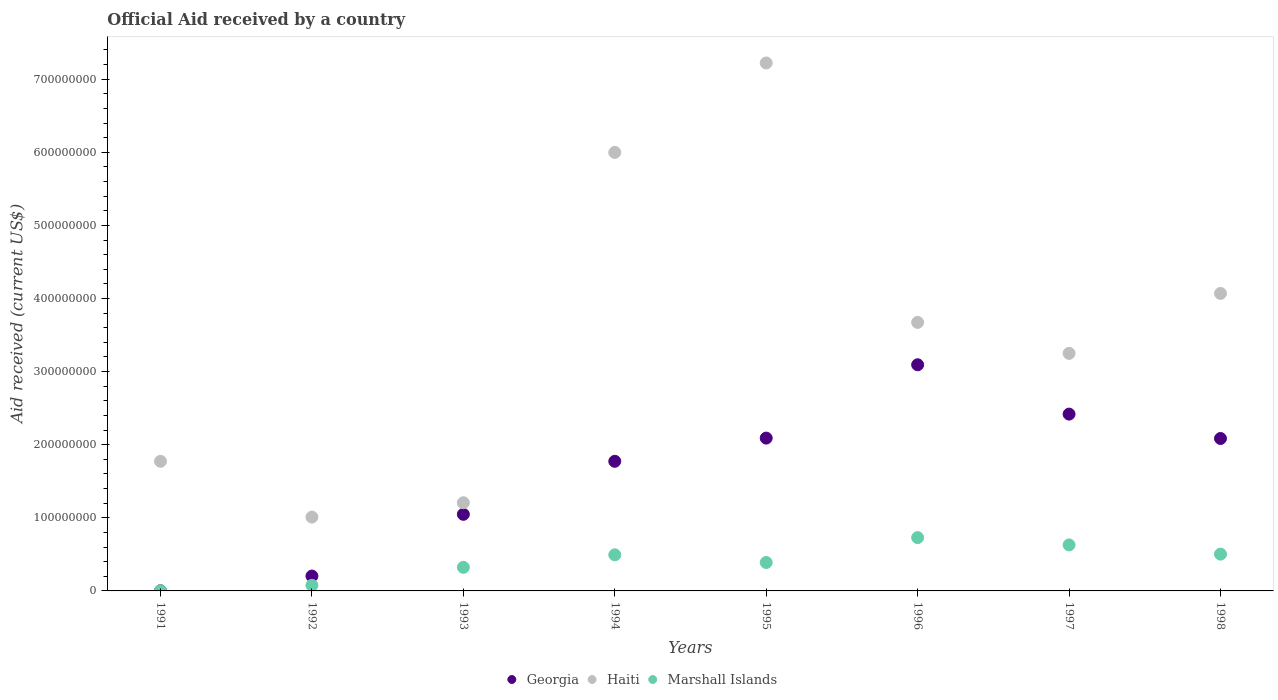How many different coloured dotlines are there?
Provide a short and direct response. 3. Is the number of dotlines equal to the number of legend labels?
Make the answer very short. Yes. What is the net official aid received in Haiti in 1991?
Your answer should be compact. 1.77e+08. Across all years, what is the maximum net official aid received in Haiti?
Offer a very short reply. 7.22e+08. Across all years, what is the minimum net official aid received in Marshall Islands?
Provide a short and direct response. 2.80e+05. In which year was the net official aid received in Haiti minimum?
Provide a succinct answer. 1992. What is the total net official aid received in Haiti in the graph?
Offer a terse response. 2.82e+09. What is the difference between the net official aid received in Georgia in 1991 and that in 1994?
Provide a succinct answer. -1.77e+08. What is the difference between the net official aid received in Georgia in 1992 and the net official aid received in Marshall Islands in 1996?
Make the answer very short. -5.26e+07. What is the average net official aid received in Haiti per year?
Ensure brevity in your answer.  3.53e+08. In the year 1996, what is the difference between the net official aid received in Georgia and net official aid received in Marshall Islands?
Give a very brief answer. 2.36e+08. In how many years, is the net official aid received in Haiti greater than 520000000 US$?
Provide a succinct answer. 2. What is the ratio of the net official aid received in Marshall Islands in 1994 to that in 1998?
Keep it short and to the point. 0.98. Is the net official aid received in Haiti in 1994 less than that in 1995?
Ensure brevity in your answer.  Yes. Is the difference between the net official aid received in Georgia in 1993 and 1997 greater than the difference between the net official aid received in Marshall Islands in 1993 and 1997?
Ensure brevity in your answer.  No. What is the difference between the highest and the second highest net official aid received in Haiti?
Offer a very short reply. 1.22e+08. What is the difference between the highest and the lowest net official aid received in Haiti?
Ensure brevity in your answer.  6.21e+08. In how many years, is the net official aid received in Haiti greater than the average net official aid received in Haiti taken over all years?
Offer a very short reply. 4. Is the sum of the net official aid received in Haiti in 1993 and 1997 greater than the maximum net official aid received in Georgia across all years?
Your answer should be compact. Yes. Is it the case that in every year, the sum of the net official aid received in Marshall Islands and net official aid received in Haiti  is greater than the net official aid received in Georgia?
Make the answer very short. Yes. Does the net official aid received in Haiti monotonically increase over the years?
Give a very brief answer. No. Is the net official aid received in Haiti strictly less than the net official aid received in Georgia over the years?
Your answer should be compact. No. How many dotlines are there?
Give a very brief answer. 3. How many years are there in the graph?
Your answer should be compact. 8. What is the difference between two consecutive major ticks on the Y-axis?
Keep it short and to the point. 1.00e+08. Are the values on the major ticks of Y-axis written in scientific E-notation?
Offer a very short reply. No. Does the graph contain any zero values?
Your answer should be very brief. No. Where does the legend appear in the graph?
Make the answer very short. Bottom center. How many legend labels are there?
Give a very brief answer. 3. What is the title of the graph?
Keep it short and to the point. Official Aid received by a country. What is the label or title of the Y-axis?
Provide a short and direct response. Aid received (current US$). What is the Aid received (current US$) of Haiti in 1991?
Offer a very short reply. 1.77e+08. What is the Aid received (current US$) in Georgia in 1992?
Your response must be concise. 2.04e+07. What is the Aid received (current US$) of Haiti in 1992?
Provide a succinct answer. 1.01e+08. What is the Aid received (current US$) in Marshall Islands in 1992?
Give a very brief answer. 7.68e+06. What is the Aid received (current US$) in Georgia in 1993?
Your answer should be very brief. 1.05e+08. What is the Aid received (current US$) in Haiti in 1993?
Make the answer very short. 1.21e+08. What is the Aid received (current US$) of Marshall Islands in 1993?
Offer a very short reply. 3.22e+07. What is the Aid received (current US$) in Georgia in 1994?
Provide a succinct answer. 1.77e+08. What is the Aid received (current US$) in Haiti in 1994?
Provide a short and direct response. 6.00e+08. What is the Aid received (current US$) in Marshall Islands in 1994?
Offer a terse response. 4.94e+07. What is the Aid received (current US$) in Georgia in 1995?
Your response must be concise. 2.09e+08. What is the Aid received (current US$) in Haiti in 1995?
Provide a succinct answer. 7.22e+08. What is the Aid received (current US$) of Marshall Islands in 1995?
Your answer should be very brief. 3.89e+07. What is the Aid received (current US$) of Georgia in 1996?
Provide a short and direct response. 3.09e+08. What is the Aid received (current US$) in Haiti in 1996?
Give a very brief answer. 3.67e+08. What is the Aid received (current US$) of Marshall Islands in 1996?
Provide a short and direct response. 7.29e+07. What is the Aid received (current US$) of Georgia in 1997?
Make the answer very short. 2.42e+08. What is the Aid received (current US$) in Haiti in 1997?
Give a very brief answer. 3.25e+08. What is the Aid received (current US$) in Marshall Islands in 1997?
Provide a succinct answer. 6.29e+07. What is the Aid received (current US$) in Georgia in 1998?
Provide a succinct answer. 2.09e+08. What is the Aid received (current US$) of Haiti in 1998?
Give a very brief answer. 4.07e+08. What is the Aid received (current US$) of Marshall Islands in 1998?
Your response must be concise. 5.03e+07. Across all years, what is the maximum Aid received (current US$) of Georgia?
Make the answer very short. 3.09e+08. Across all years, what is the maximum Aid received (current US$) in Haiti?
Make the answer very short. 7.22e+08. Across all years, what is the maximum Aid received (current US$) of Marshall Islands?
Offer a terse response. 7.29e+07. Across all years, what is the minimum Aid received (current US$) in Haiti?
Keep it short and to the point. 1.01e+08. What is the total Aid received (current US$) of Georgia in the graph?
Offer a very short reply. 1.27e+09. What is the total Aid received (current US$) of Haiti in the graph?
Ensure brevity in your answer.  2.82e+09. What is the total Aid received (current US$) in Marshall Islands in the graph?
Ensure brevity in your answer.  3.15e+08. What is the difference between the Aid received (current US$) of Georgia in 1991 and that in 1992?
Your response must be concise. -2.01e+07. What is the difference between the Aid received (current US$) in Haiti in 1991 and that in 1992?
Offer a very short reply. 7.63e+07. What is the difference between the Aid received (current US$) of Marshall Islands in 1991 and that in 1992?
Ensure brevity in your answer.  -7.40e+06. What is the difference between the Aid received (current US$) of Georgia in 1991 and that in 1993?
Make the answer very short. -1.05e+08. What is the difference between the Aid received (current US$) in Haiti in 1991 and that in 1993?
Keep it short and to the point. 5.66e+07. What is the difference between the Aid received (current US$) of Marshall Islands in 1991 and that in 1993?
Offer a very short reply. -3.20e+07. What is the difference between the Aid received (current US$) in Georgia in 1991 and that in 1994?
Provide a short and direct response. -1.77e+08. What is the difference between the Aid received (current US$) in Haiti in 1991 and that in 1994?
Your answer should be very brief. -4.23e+08. What is the difference between the Aid received (current US$) of Marshall Islands in 1991 and that in 1994?
Your answer should be very brief. -4.91e+07. What is the difference between the Aid received (current US$) in Georgia in 1991 and that in 1995?
Ensure brevity in your answer.  -2.09e+08. What is the difference between the Aid received (current US$) in Haiti in 1991 and that in 1995?
Give a very brief answer. -5.45e+08. What is the difference between the Aid received (current US$) of Marshall Islands in 1991 and that in 1995?
Offer a very short reply. -3.86e+07. What is the difference between the Aid received (current US$) of Georgia in 1991 and that in 1996?
Ensure brevity in your answer.  -3.09e+08. What is the difference between the Aid received (current US$) of Haiti in 1991 and that in 1996?
Make the answer very short. -1.90e+08. What is the difference between the Aid received (current US$) in Marshall Islands in 1991 and that in 1996?
Make the answer very short. -7.27e+07. What is the difference between the Aid received (current US$) in Georgia in 1991 and that in 1997?
Give a very brief answer. -2.42e+08. What is the difference between the Aid received (current US$) of Haiti in 1991 and that in 1997?
Your response must be concise. -1.48e+08. What is the difference between the Aid received (current US$) of Marshall Islands in 1991 and that in 1997?
Offer a very short reply. -6.26e+07. What is the difference between the Aid received (current US$) of Georgia in 1991 and that in 1998?
Your response must be concise. -2.08e+08. What is the difference between the Aid received (current US$) of Haiti in 1991 and that in 1998?
Provide a short and direct response. -2.30e+08. What is the difference between the Aid received (current US$) in Marshall Islands in 1991 and that in 1998?
Your answer should be compact. -5.00e+07. What is the difference between the Aid received (current US$) of Georgia in 1992 and that in 1993?
Ensure brevity in your answer.  -8.44e+07. What is the difference between the Aid received (current US$) in Haiti in 1992 and that in 1993?
Your answer should be compact. -1.97e+07. What is the difference between the Aid received (current US$) in Marshall Islands in 1992 and that in 1993?
Provide a short and direct response. -2.46e+07. What is the difference between the Aid received (current US$) in Georgia in 1992 and that in 1994?
Your answer should be compact. -1.57e+08. What is the difference between the Aid received (current US$) in Haiti in 1992 and that in 1994?
Give a very brief answer. -4.99e+08. What is the difference between the Aid received (current US$) in Marshall Islands in 1992 and that in 1994?
Your response must be concise. -4.17e+07. What is the difference between the Aid received (current US$) of Georgia in 1992 and that in 1995?
Offer a very short reply. -1.89e+08. What is the difference between the Aid received (current US$) of Haiti in 1992 and that in 1995?
Your answer should be compact. -6.21e+08. What is the difference between the Aid received (current US$) of Marshall Islands in 1992 and that in 1995?
Provide a short and direct response. -3.12e+07. What is the difference between the Aid received (current US$) of Georgia in 1992 and that in 1996?
Your answer should be compact. -2.89e+08. What is the difference between the Aid received (current US$) in Haiti in 1992 and that in 1996?
Ensure brevity in your answer.  -2.66e+08. What is the difference between the Aid received (current US$) in Marshall Islands in 1992 and that in 1996?
Your answer should be very brief. -6.53e+07. What is the difference between the Aid received (current US$) in Georgia in 1992 and that in 1997?
Give a very brief answer. -2.22e+08. What is the difference between the Aid received (current US$) in Haiti in 1992 and that in 1997?
Provide a short and direct response. -2.24e+08. What is the difference between the Aid received (current US$) of Marshall Islands in 1992 and that in 1997?
Your answer should be compact. -5.52e+07. What is the difference between the Aid received (current US$) of Georgia in 1992 and that in 1998?
Keep it short and to the point. -1.88e+08. What is the difference between the Aid received (current US$) of Haiti in 1992 and that in 1998?
Provide a short and direct response. -3.06e+08. What is the difference between the Aid received (current US$) in Marshall Islands in 1992 and that in 1998?
Your answer should be very brief. -4.26e+07. What is the difference between the Aid received (current US$) in Georgia in 1993 and that in 1994?
Your answer should be compact. -7.25e+07. What is the difference between the Aid received (current US$) in Haiti in 1993 and that in 1994?
Offer a very short reply. -4.79e+08. What is the difference between the Aid received (current US$) of Marshall Islands in 1993 and that in 1994?
Make the answer very short. -1.71e+07. What is the difference between the Aid received (current US$) of Georgia in 1993 and that in 1995?
Your response must be concise. -1.04e+08. What is the difference between the Aid received (current US$) in Haiti in 1993 and that in 1995?
Ensure brevity in your answer.  -6.02e+08. What is the difference between the Aid received (current US$) in Marshall Islands in 1993 and that in 1995?
Offer a terse response. -6.63e+06. What is the difference between the Aid received (current US$) in Georgia in 1993 and that in 1996?
Your answer should be very brief. -2.05e+08. What is the difference between the Aid received (current US$) of Haiti in 1993 and that in 1996?
Your answer should be compact. -2.47e+08. What is the difference between the Aid received (current US$) in Marshall Islands in 1993 and that in 1996?
Give a very brief answer. -4.07e+07. What is the difference between the Aid received (current US$) of Georgia in 1993 and that in 1997?
Your answer should be very brief. -1.37e+08. What is the difference between the Aid received (current US$) in Haiti in 1993 and that in 1997?
Make the answer very short. -2.04e+08. What is the difference between the Aid received (current US$) in Marshall Islands in 1993 and that in 1997?
Make the answer very short. -3.07e+07. What is the difference between the Aid received (current US$) in Georgia in 1993 and that in 1998?
Provide a short and direct response. -1.04e+08. What is the difference between the Aid received (current US$) of Haiti in 1993 and that in 1998?
Make the answer very short. -2.86e+08. What is the difference between the Aid received (current US$) of Marshall Islands in 1993 and that in 1998?
Your answer should be very brief. -1.81e+07. What is the difference between the Aid received (current US$) in Georgia in 1994 and that in 1995?
Give a very brief answer. -3.17e+07. What is the difference between the Aid received (current US$) in Haiti in 1994 and that in 1995?
Provide a short and direct response. -1.22e+08. What is the difference between the Aid received (current US$) in Marshall Islands in 1994 and that in 1995?
Ensure brevity in your answer.  1.05e+07. What is the difference between the Aid received (current US$) in Georgia in 1994 and that in 1996?
Your answer should be very brief. -1.32e+08. What is the difference between the Aid received (current US$) in Haiti in 1994 and that in 1996?
Your response must be concise. 2.33e+08. What is the difference between the Aid received (current US$) of Marshall Islands in 1994 and that in 1996?
Offer a terse response. -2.36e+07. What is the difference between the Aid received (current US$) in Georgia in 1994 and that in 1997?
Make the answer very short. -6.46e+07. What is the difference between the Aid received (current US$) of Haiti in 1994 and that in 1997?
Offer a terse response. 2.75e+08. What is the difference between the Aid received (current US$) of Marshall Islands in 1994 and that in 1997?
Your answer should be compact. -1.36e+07. What is the difference between the Aid received (current US$) of Georgia in 1994 and that in 1998?
Provide a short and direct response. -3.12e+07. What is the difference between the Aid received (current US$) in Haiti in 1994 and that in 1998?
Provide a short and direct response. 1.93e+08. What is the difference between the Aid received (current US$) in Marshall Islands in 1994 and that in 1998?
Your answer should be compact. -9.70e+05. What is the difference between the Aid received (current US$) of Georgia in 1995 and that in 1996?
Provide a succinct answer. -1.00e+08. What is the difference between the Aid received (current US$) of Haiti in 1995 and that in 1996?
Your answer should be compact. 3.55e+08. What is the difference between the Aid received (current US$) in Marshall Islands in 1995 and that in 1996?
Your answer should be very brief. -3.41e+07. What is the difference between the Aid received (current US$) in Georgia in 1995 and that in 1997?
Offer a terse response. -3.28e+07. What is the difference between the Aid received (current US$) in Haiti in 1995 and that in 1997?
Ensure brevity in your answer.  3.97e+08. What is the difference between the Aid received (current US$) in Marshall Islands in 1995 and that in 1997?
Your answer should be very brief. -2.40e+07. What is the difference between the Aid received (current US$) in Georgia in 1995 and that in 1998?
Your answer should be very brief. 5.40e+05. What is the difference between the Aid received (current US$) in Haiti in 1995 and that in 1998?
Offer a very short reply. 3.15e+08. What is the difference between the Aid received (current US$) of Marshall Islands in 1995 and that in 1998?
Your response must be concise. -1.14e+07. What is the difference between the Aid received (current US$) in Georgia in 1996 and that in 1997?
Your response must be concise. 6.75e+07. What is the difference between the Aid received (current US$) of Haiti in 1996 and that in 1997?
Make the answer very short. 4.23e+07. What is the difference between the Aid received (current US$) in Marshall Islands in 1996 and that in 1997?
Offer a terse response. 1.00e+07. What is the difference between the Aid received (current US$) in Georgia in 1996 and that in 1998?
Provide a succinct answer. 1.01e+08. What is the difference between the Aid received (current US$) in Haiti in 1996 and that in 1998?
Offer a very short reply. -3.97e+07. What is the difference between the Aid received (current US$) in Marshall Islands in 1996 and that in 1998?
Offer a terse response. 2.26e+07. What is the difference between the Aid received (current US$) of Georgia in 1997 and that in 1998?
Offer a terse response. 3.34e+07. What is the difference between the Aid received (current US$) in Haiti in 1997 and that in 1998?
Offer a very short reply. -8.20e+07. What is the difference between the Aid received (current US$) in Marshall Islands in 1997 and that in 1998?
Ensure brevity in your answer.  1.26e+07. What is the difference between the Aid received (current US$) of Georgia in 1991 and the Aid received (current US$) of Haiti in 1992?
Keep it short and to the point. -1.01e+08. What is the difference between the Aid received (current US$) in Georgia in 1991 and the Aid received (current US$) in Marshall Islands in 1992?
Your response must be concise. -7.47e+06. What is the difference between the Aid received (current US$) of Haiti in 1991 and the Aid received (current US$) of Marshall Islands in 1992?
Ensure brevity in your answer.  1.70e+08. What is the difference between the Aid received (current US$) in Georgia in 1991 and the Aid received (current US$) in Haiti in 1993?
Make the answer very short. -1.20e+08. What is the difference between the Aid received (current US$) of Georgia in 1991 and the Aid received (current US$) of Marshall Islands in 1993?
Offer a very short reply. -3.20e+07. What is the difference between the Aid received (current US$) in Haiti in 1991 and the Aid received (current US$) in Marshall Islands in 1993?
Give a very brief answer. 1.45e+08. What is the difference between the Aid received (current US$) of Georgia in 1991 and the Aid received (current US$) of Haiti in 1994?
Your answer should be very brief. -6.00e+08. What is the difference between the Aid received (current US$) in Georgia in 1991 and the Aid received (current US$) in Marshall Islands in 1994?
Keep it short and to the point. -4.92e+07. What is the difference between the Aid received (current US$) of Haiti in 1991 and the Aid received (current US$) of Marshall Islands in 1994?
Offer a terse response. 1.28e+08. What is the difference between the Aid received (current US$) of Georgia in 1991 and the Aid received (current US$) of Haiti in 1995?
Provide a succinct answer. -7.22e+08. What is the difference between the Aid received (current US$) of Georgia in 1991 and the Aid received (current US$) of Marshall Islands in 1995?
Provide a succinct answer. -3.87e+07. What is the difference between the Aid received (current US$) in Haiti in 1991 and the Aid received (current US$) in Marshall Islands in 1995?
Your response must be concise. 1.38e+08. What is the difference between the Aid received (current US$) in Georgia in 1991 and the Aid received (current US$) in Haiti in 1996?
Offer a very short reply. -3.67e+08. What is the difference between the Aid received (current US$) of Georgia in 1991 and the Aid received (current US$) of Marshall Islands in 1996?
Your answer should be very brief. -7.27e+07. What is the difference between the Aid received (current US$) in Haiti in 1991 and the Aid received (current US$) in Marshall Islands in 1996?
Provide a succinct answer. 1.04e+08. What is the difference between the Aid received (current US$) of Georgia in 1991 and the Aid received (current US$) of Haiti in 1997?
Keep it short and to the point. -3.25e+08. What is the difference between the Aid received (current US$) in Georgia in 1991 and the Aid received (current US$) in Marshall Islands in 1997?
Offer a terse response. -6.27e+07. What is the difference between the Aid received (current US$) in Haiti in 1991 and the Aid received (current US$) in Marshall Islands in 1997?
Your answer should be compact. 1.14e+08. What is the difference between the Aid received (current US$) of Georgia in 1991 and the Aid received (current US$) of Haiti in 1998?
Offer a very short reply. -4.07e+08. What is the difference between the Aid received (current US$) in Georgia in 1991 and the Aid received (current US$) in Marshall Islands in 1998?
Provide a short and direct response. -5.01e+07. What is the difference between the Aid received (current US$) of Haiti in 1991 and the Aid received (current US$) of Marshall Islands in 1998?
Keep it short and to the point. 1.27e+08. What is the difference between the Aid received (current US$) of Georgia in 1992 and the Aid received (current US$) of Haiti in 1993?
Offer a terse response. -1.00e+08. What is the difference between the Aid received (current US$) in Georgia in 1992 and the Aid received (current US$) in Marshall Islands in 1993?
Ensure brevity in your answer.  -1.19e+07. What is the difference between the Aid received (current US$) in Haiti in 1992 and the Aid received (current US$) in Marshall Islands in 1993?
Your answer should be very brief. 6.87e+07. What is the difference between the Aid received (current US$) in Georgia in 1992 and the Aid received (current US$) in Haiti in 1994?
Give a very brief answer. -5.79e+08. What is the difference between the Aid received (current US$) in Georgia in 1992 and the Aid received (current US$) in Marshall Islands in 1994?
Your answer should be compact. -2.90e+07. What is the difference between the Aid received (current US$) in Haiti in 1992 and the Aid received (current US$) in Marshall Islands in 1994?
Keep it short and to the point. 5.16e+07. What is the difference between the Aid received (current US$) of Georgia in 1992 and the Aid received (current US$) of Haiti in 1995?
Keep it short and to the point. -7.02e+08. What is the difference between the Aid received (current US$) of Georgia in 1992 and the Aid received (current US$) of Marshall Islands in 1995?
Your response must be concise. -1.85e+07. What is the difference between the Aid received (current US$) of Haiti in 1992 and the Aid received (current US$) of Marshall Islands in 1995?
Provide a succinct answer. 6.21e+07. What is the difference between the Aid received (current US$) of Georgia in 1992 and the Aid received (current US$) of Haiti in 1996?
Make the answer very short. -3.47e+08. What is the difference between the Aid received (current US$) in Georgia in 1992 and the Aid received (current US$) in Marshall Islands in 1996?
Your answer should be very brief. -5.26e+07. What is the difference between the Aid received (current US$) of Haiti in 1992 and the Aid received (current US$) of Marshall Islands in 1996?
Keep it short and to the point. 2.80e+07. What is the difference between the Aid received (current US$) of Georgia in 1992 and the Aid received (current US$) of Haiti in 1997?
Offer a terse response. -3.05e+08. What is the difference between the Aid received (current US$) in Georgia in 1992 and the Aid received (current US$) in Marshall Islands in 1997?
Offer a very short reply. -4.26e+07. What is the difference between the Aid received (current US$) in Haiti in 1992 and the Aid received (current US$) in Marshall Islands in 1997?
Your answer should be compact. 3.80e+07. What is the difference between the Aid received (current US$) of Georgia in 1992 and the Aid received (current US$) of Haiti in 1998?
Make the answer very short. -3.87e+08. What is the difference between the Aid received (current US$) in Georgia in 1992 and the Aid received (current US$) in Marshall Islands in 1998?
Keep it short and to the point. -3.00e+07. What is the difference between the Aid received (current US$) in Haiti in 1992 and the Aid received (current US$) in Marshall Islands in 1998?
Your answer should be very brief. 5.06e+07. What is the difference between the Aid received (current US$) in Georgia in 1993 and the Aid received (current US$) in Haiti in 1994?
Offer a terse response. -4.95e+08. What is the difference between the Aid received (current US$) of Georgia in 1993 and the Aid received (current US$) of Marshall Islands in 1994?
Provide a short and direct response. 5.54e+07. What is the difference between the Aid received (current US$) of Haiti in 1993 and the Aid received (current US$) of Marshall Islands in 1994?
Provide a short and direct response. 7.13e+07. What is the difference between the Aid received (current US$) of Georgia in 1993 and the Aid received (current US$) of Haiti in 1995?
Provide a succinct answer. -6.17e+08. What is the difference between the Aid received (current US$) of Georgia in 1993 and the Aid received (current US$) of Marshall Islands in 1995?
Provide a succinct answer. 6.59e+07. What is the difference between the Aid received (current US$) in Haiti in 1993 and the Aid received (current US$) in Marshall Islands in 1995?
Ensure brevity in your answer.  8.18e+07. What is the difference between the Aid received (current US$) in Georgia in 1993 and the Aid received (current US$) in Haiti in 1996?
Offer a very short reply. -2.63e+08. What is the difference between the Aid received (current US$) of Georgia in 1993 and the Aid received (current US$) of Marshall Islands in 1996?
Give a very brief answer. 3.18e+07. What is the difference between the Aid received (current US$) in Haiti in 1993 and the Aid received (current US$) in Marshall Islands in 1996?
Provide a short and direct response. 4.77e+07. What is the difference between the Aid received (current US$) of Georgia in 1993 and the Aid received (current US$) of Haiti in 1997?
Give a very brief answer. -2.20e+08. What is the difference between the Aid received (current US$) in Georgia in 1993 and the Aid received (current US$) in Marshall Islands in 1997?
Provide a succinct answer. 4.18e+07. What is the difference between the Aid received (current US$) in Haiti in 1993 and the Aid received (current US$) in Marshall Islands in 1997?
Your answer should be very brief. 5.77e+07. What is the difference between the Aid received (current US$) of Georgia in 1993 and the Aid received (current US$) of Haiti in 1998?
Keep it short and to the point. -3.02e+08. What is the difference between the Aid received (current US$) in Georgia in 1993 and the Aid received (current US$) in Marshall Islands in 1998?
Your answer should be very brief. 5.44e+07. What is the difference between the Aid received (current US$) of Haiti in 1993 and the Aid received (current US$) of Marshall Islands in 1998?
Your response must be concise. 7.03e+07. What is the difference between the Aid received (current US$) of Georgia in 1994 and the Aid received (current US$) of Haiti in 1995?
Your response must be concise. -5.45e+08. What is the difference between the Aid received (current US$) of Georgia in 1994 and the Aid received (current US$) of Marshall Islands in 1995?
Make the answer very short. 1.38e+08. What is the difference between the Aid received (current US$) of Haiti in 1994 and the Aid received (current US$) of Marshall Islands in 1995?
Your response must be concise. 5.61e+08. What is the difference between the Aid received (current US$) in Georgia in 1994 and the Aid received (current US$) in Haiti in 1996?
Your response must be concise. -1.90e+08. What is the difference between the Aid received (current US$) of Georgia in 1994 and the Aid received (current US$) of Marshall Islands in 1996?
Provide a short and direct response. 1.04e+08. What is the difference between the Aid received (current US$) in Haiti in 1994 and the Aid received (current US$) in Marshall Islands in 1996?
Keep it short and to the point. 5.27e+08. What is the difference between the Aid received (current US$) in Georgia in 1994 and the Aid received (current US$) in Haiti in 1997?
Offer a very short reply. -1.48e+08. What is the difference between the Aid received (current US$) in Georgia in 1994 and the Aid received (current US$) in Marshall Islands in 1997?
Provide a short and direct response. 1.14e+08. What is the difference between the Aid received (current US$) of Haiti in 1994 and the Aid received (current US$) of Marshall Islands in 1997?
Give a very brief answer. 5.37e+08. What is the difference between the Aid received (current US$) in Georgia in 1994 and the Aid received (current US$) in Haiti in 1998?
Provide a short and direct response. -2.30e+08. What is the difference between the Aid received (current US$) of Georgia in 1994 and the Aid received (current US$) of Marshall Islands in 1998?
Offer a terse response. 1.27e+08. What is the difference between the Aid received (current US$) in Haiti in 1994 and the Aid received (current US$) in Marshall Islands in 1998?
Offer a terse response. 5.50e+08. What is the difference between the Aid received (current US$) of Georgia in 1995 and the Aid received (current US$) of Haiti in 1996?
Your response must be concise. -1.58e+08. What is the difference between the Aid received (current US$) of Georgia in 1995 and the Aid received (current US$) of Marshall Islands in 1996?
Keep it short and to the point. 1.36e+08. What is the difference between the Aid received (current US$) of Haiti in 1995 and the Aid received (current US$) of Marshall Islands in 1996?
Ensure brevity in your answer.  6.49e+08. What is the difference between the Aid received (current US$) in Georgia in 1995 and the Aid received (current US$) in Haiti in 1997?
Provide a succinct answer. -1.16e+08. What is the difference between the Aid received (current US$) of Georgia in 1995 and the Aid received (current US$) of Marshall Islands in 1997?
Your answer should be compact. 1.46e+08. What is the difference between the Aid received (current US$) of Haiti in 1995 and the Aid received (current US$) of Marshall Islands in 1997?
Offer a terse response. 6.59e+08. What is the difference between the Aid received (current US$) of Georgia in 1995 and the Aid received (current US$) of Haiti in 1998?
Your response must be concise. -1.98e+08. What is the difference between the Aid received (current US$) in Georgia in 1995 and the Aid received (current US$) in Marshall Islands in 1998?
Provide a succinct answer. 1.59e+08. What is the difference between the Aid received (current US$) in Haiti in 1995 and the Aid received (current US$) in Marshall Islands in 1998?
Offer a very short reply. 6.72e+08. What is the difference between the Aid received (current US$) in Georgia in 1996 and the Aid received (current US$) in Haiti in 1997?
Offer a terse response. -1.56e+07. What is the difference between the Aid received (current US$) in Georgia in 1996 and the Aid received (current US$) in Marshall Islands in 1997?
Provide a succinct answer. 2.46e+08. What is the difference between the Aid received (current US$) of Haiti in 1996 and the Aid received (current US$) of Marshall Islands in 1997?
Make the answer very short. 3.04e+08. What is the difference between the Aid received (current US$) of Georgia in 1996 and the Aid received (current US$) of Haiti in 1998?
Offer a terse response. -9.76e+07. What is the difference between the Aid received (current US$) of Georgia in 1996 and the Aid received (current US$) of Marshall Islands in 1998?
Keep it short and to the point. 2.59e+08. What is the difference between the Aid received (current US$) of Haiti in 1996 and the Aid received (current US$) of Marshall Islands in 1998?
Ensure brevity in your answer.  3.17e+08. What is the difference between the Aid received (current US$) of Georgia in 1997 and the Aid received (current US$) of Haiti in 1998?
Make the answer very short. -1.65e+08. What is the difference between the Aid received (current US$) in Georgia in 1997 and the Aid received (current US$) in Marshall Islands in 1998?
Your answer should be compact. 1.92e+08. What is the difference between the Aid received (current US$) in Haiti in 1997 and the Aid received (current US$) in Marshall Islands in 1998?
Provide a succinct answer. 2.75e+08. What is the average Aid received (current US$) in Georgia per year?
Make the answer very short. 1.59e+08. What is the average Aid received (current US$) of Haiti per year?
Provide a succinct answer. 3.53e+08. What is the average Aid received (current US$) in Marshall Islands per year?
Give a very brief answer. 3.93e+07. In the year 1991, what is the difference between the Aid received (current US$) in Georgia and Aid received (current US$) in Haiti?
Ensure brevity in your answer.  -1.77e+08. In the year 1991, what is the difference between the Aid received (current US$) of Haiti and Aid received (current US$) of Marshall Islands?
Ensure brevity in your answer.  1.77e+08. In the year 1992, what is the difference between the Aid received (current US$) in Georgia and Aid received (current US$) in Haiti?
Offer a very short reply. -8.06e+07. In the year 1992, what is the difference between the Aid received (current US$) in Georgia and Aid received (current US$) in Marshall Islands?
Make the answer very short. 1.27e+07. In the year 1992, what is the difference between the Aid received (current US$) in Haiti and Aid received (current US$) in Marshall Islands?
Your answer should be very brief. 9.33e+07. In the year 1993, what is the difference between the Aid received (current US$) of Georgia and Aid received (current US$) of Haiti?
Keep it short and to the point. -1.59e+07. In the year 1993, what is the difference between the Aid received (current US$) of Georgia and Aid received (current US$) of Marshall Islands?
Ensure brevity in your answer.  7.25e+07. In the year 1993, what is the difference between the Aid received (current US$) of Haiti and Aid received (current US$) of Marshall Islands?
Provide a short and direct response. 8.84e+07. In the year 1994, what is the difference between the Aid received (current US$) in Georgia and Aid received (current US$) in Haiti?
Ensure brevity in your answer.  -4.23e+08. In the year 1994, what is the difference between the Aid received (current US$) in Georgia and Aid received (current US$) in Marshall Islands?
Offer a terse response. 1.28e+08. In the year 1994, what is the difference between the Aid received (current US$) in Haiti and Aid received (current US$) in Marshall Islands?
Give a very brief answer. 5.50e+08. In the year 1995, what is the difference between the Aid received (current US$) of Georgia and Aid received (current US$) of Haiti?
Make the answer very short. -5.13e+08. In the year 1995, what is the difference between the Aid received (current US$) of Georgia and Aid received (current US$) of Marshall Islands?
Give a very brief answer. 1.70e+08. In the year 1995, what is the difference between the Aid received (current US$) of Haiti and Aid received (current US$) of Marshall Islands?
Offer a terse response. 6.83e+08. In the year 1996, what is the difference between the Aid received (current US$) of Georgia and Aid received (current US$) of Haiti?
Make the answer very short. -5.79e+07. In the year 1996, what is the difference between the Aid received (current US$) of Georgia and Aid received (current US$) of Marshall Islands?
Your answer should be compact. 2.36e+08. In the year 1996, what is the difference between the Aid received (current US$) in Haiti and Aid received (current US$) in Marshall Islands?
Your response must be concise. 2.94e+08. In the year 1997, what is the difference between the Aid received (current US$) in Georgia and Aid received (current US$) in Haiti?
Provide a succinct answer. -8.31e+07. In the year 1997, what is the difference between the Aid received (current US$) of Georgia and Aid received (current US$) of Marshall Islands?
Your answer should be very brief. 1.79e+08. In the year 1997, what is the difference between the Aid received (current US$) of Haiti and Aid received (current US$) of Marshall Islands?
Provide a short and direct response. 2.62e+08. In the year 1998, what is the difference between the Aid received (current US$) in Georgia and Aid received (current US$) in Haiti?
Ensure brevity in your answer.  -1.98e+08. In the year 1998, what is the difference between the Aid received (current US$) in Georgia and Aid received (current US$) in Marshall Islands?
Give a very brief answer. 1.58e+08. In the year 1998, what is the difference between the Aid received (current US$) in Haiti and Aid received (current US$) in Marshall Islands?
Provide a succinct answer. 3.57e+08. What is the ratio of the Aid received (current US$) of Georgia in 1991 to that in 1992?
Offer a very short reply. 0.01. What is the ratio of the Aid received (current US$) in Haiti in 1991 to that in 1992?
Provide a short and direct response. 1.76. What is the ratio of the Aid received (current US$) of Marshall Islands in 1991 to that in 1992?
Your answer should be very brief. 0.04. What is the ratio of the Aid received (current US$) in Georgia in 1991 to that in 1993?
Keep it short and to the point. 0. What is the ratio of the Aid received (current US$) of Haiti in 1991 to that in 1993?
Your answer should be compact. 1.47. What is the ratio of the Aid received (current US$) of Marshall Islands in 1991 to that in 1993?
Offer a very short reply. 0.01. What is the ratio of the Aid received (current US$) of Georgia in 1991 to that in 1994?
Your answer should be very brief. 0. What is the ratio of the Aid received (current US$) in Haiti in 1991 to that in 1994?
Provide a succinct answer. 0.3. What is the ratio of the Aid received (current US$) of Marshall Islands in 1991 to that in 1994?
Make the answer very short. 0.01. What is the ratio of the Aid received (current US$) in Georgia in 1991 to that in 1995?
Make the answer very short. 0. What is the ratio of the Aid received (current US$) in Haiti in 1991 to that in 1995?
Provide a short and direct response. 0.25. What is the ratio of the Aid received (current US$) of Marshall Islands in 1991 to that in 1995?
Your answer should be very brief. 0.01. What is the ratio of the Aid received (current US$) of Georgia in 1991 to that in 1996?
Offer a very short reply. 0. What is the ratio of the Aid received (current US$) of Haiti in 1991 to that in 1996?
Provide a short and direct response. 0.48. What is the ratio of the Aid received (current US$) in Marshall Islands in 1991 to that in 1996?
Offer a very short reply. 0. What is the ratio of the Aid received (current US$) of Georgia in 1991 to that in 1997?
Offer a terse response. 0. What is the ratio of the Aid received (current US$) of Haiti in 1991 to that in 1997?
Make the answer very short. 0.55. What is the ratio of the Aid received (current US$) of Marshall Islands in 1991 to that in 1997?
Your answer should be very brief. 0. What is the ratio of the Aid received (current US$) in Haiti in 1991 to that in 1998?
Give a very brief answer. 0.44. What is the ratio of the Aid received (current US$) of Marshall Islands in 1991 to that in 1998?
Offer a very short reply. 0.01. What is the ratio of the Aid received (current US$) of Georgia in 1992 to that in 1993?
Your answer should be very brief. 0.19. What is the ratio of the Aid received (current US$) in Haiti in 1992 to that in 1993?
Your response must be concise. 0.84. What is the ratio of the Aid received (current US$) in Marshall Islands in 1992 to that in 1993?
Your response must be concise. 0.24. What is the ratio of the Aid received (current US$) of Georgia in 1992 to that in 1994?
Make the answer very short. 0.11. What is the ratio of the Aid received (current US$) in Haiti in 1992 to that in 1994?
Offer a very short reply. 0.17. What is the ratio of the Aid received (current US$) of Marshall Islands in 1992 to that in 1994?
Provide a short and direct response. 0.16. What is the ratio of the Aid received (current US$) in Georgia in 1992 to that in 1995?
Make the answer very short. 0.1. What is the ratio of the Aid received (current US$) in Haiti in 1992 to that in 1995?
Your response must be concise. 0.14. What is the ratio of the Aid received (current US$) of Marshall Islands in 1992 to that in 1995?
Offer a very short reply. 0.2. What is the ratio of the Aid received (current US$) of Georgia in 1992 to that in 1996?
Offer a very short reply. 0.07. What is the ratio of the Aid received (current US$) in Haiti in 1992 to that in 1996?
Ensure brevity in your answer.  0.27. What is the ratio of the Aid received (current US$) of Marshall Islands in 1992 to that in 1996?
Your answer should be compact. 0.11. What is the ratio of the Aid received (current US$) in Georgia in 1992 to that in 1997?
Provide a succinct answer. 0.08. What is the ratio of the Aid received (current US$) of Haiti in 1992 to that in 1997?
Make the answer very short. 0.31. What is the ratio of the Aid received (current US$) in Marshall Islands in 1992 to that in 1997?
Make the answer very short. 0.12. What is the ratio of the Aid received (current US$) of Georgia in 1992 to that in 1998?
Your response must be concise. 0.1. What is the ratio of the Aid received (current US$) of Haiti in 1992 to that in 1998?
Provide a succinct answer. 0.25. What is the ratio of the Aid received (current US$) in Marshall Islands in 1992 to that in 1998?
Give a very brief answer. 0.15. What is the ratio of the Aid received (current US$) of Georgia in 1993 to that in 1994?
Give a very brief answer. 0.59. What is the ratio of the Aid received (current US$) in Haiti in 1993 to that in 1994?
Provide a succinct answer. 0.2. What is the ratio of the Aid received (current US$) in Marshall Islands in 1993 to that in 1994?
Make the answer very short. 0.65. What is the ratio of the Aid received (current US$) in Georgia in 1993 to that in 1995?
Provide a short and direct response. 0.5. What is the ratio of the Aid received (current US$) of Haiti in 1993 to that in 1995?
Your response must be concise. 0.17. What is the ratio of the Aid received (current US$) of Marshall Islands in 1993 to that in 1995?
Make the answer very short. 0.83. What is the ratio of the Aid received (current US$) of Georgia in 1993 to that in 1996?
Offer a terse response. 0.34. What is the ratio of the Aid received (current US$) in Haiti in 1993 to that in 1996?
Offer a terse response. 0.33. What is the ratio of the Aid received (current US$) in Marshall Islands in 1993 to that in 1996?
Offer a very short reply. 0.44. What is the ratio of the Aid received (current US$) in Georgia in 1993 to that in 1997?
Keep it short and to the point. 0.43. What is the ratio of the Aid received (current US$) of Haiti in 1993 to that in 1997?
Offer a terse response. 0.37. What is the ratio of the Aid received (current US$) of Marshall Islands in 1993 to that in 1997?
Your answer should be compact. 0.51. What is the ratio of the Aid received (current US$) of Georgia in 1993 to that in 1998?
Your answer should be very brief. 0.5. What is the ratio of the Aid received (current US$) in Haiti in 1993 to that in 1998?
Keep it short and to the point. 0.3. What is the ratio of the Aid received (current US$) in Marshall Islands in 1993 to that in 1998?
Offer a terse response. 0.64. What is the ratio of the Aid received (current US$) of Georgia in 1994 to that in 1995?
Give a very brief answer. 0.85. What is the ratio of the Aid received (current US$) in Haiti in 1994 to that in 1995?
Offer a terse response. 0.83. What is the ratio of the Aid received (current US$) in Marshall Islands in 1994 to that in 1995?
Ensure brevity in your answer.  1.27. What is the ratio of the Aid received (current US$) in Georgia in 1994 to that in 1996?
Provide a succinct answer. 0.57. What is the ratio of the Aid received (current US$) in Haiti in 1994 to that in 1996?
Give a very brief answer. 1.63. What is the ratio of the Aid received (current US$) in Marshall Islands in 1994 to that in 1996?
Your response must be concise. 0.68. What is the ratio of the Aid received (current US$) of Georgia in 1994 to that in 1997?
Provide a succinct answer. 0.73. What is the ratio of the Aid received (current US$) in Haiti in 1994 to that in 1997?
Offer a terse response. 1.85. What is the ratio of the Aid received (current US$) of Marshall Islands in 1994 to that in 1997?
Your response must be concise. 0.78. What is the ratio of the Aid received (current US$) of Georgia in 1994 to that in 1998?
Keep it short and to the point. 0.85. What is the ratio of the Aid received (current US$) of Haiti in 1994 to that in 1998?
Your answer should be compact. 1.47. What is the ratio of the Aid received (current US$) in Marshall Islands in 1994 to that in 1998?
Your answer should be compact. 0.98. What is the ratio of the Aid received (current US$) of Georgia in 1995 to that in 1996?
Provide a succinct answer. 0.68. What is the ratio of the Aid received (current US$) of Haiti in 1995 to that in 1996?
Provide a short and direct response. 1.97. What is the ratio of the Aid received (current US$) of Marshall Islands in 1995 to that in 1996?
Your answer should be very brief. 0.53. What is the ratio of the Aid received (current US$) of Georgia in 1995 to that in 1997?
Give a very brief answer. 0.86. What is the ratio of the Aid received (current US$) of Haiti in 1995 to that in 1997?
Ensure brevity in your answer.  2.22. What is the ratio of the Aid received (current US$) of Marshall Islands in 1995 to that in 1997?
Offer a terse response. 0.62. What is the ratio of the Aid received (current US$) of Haiti in 1995 to that in 1998?
Offer a terse response. 1.77. What is the ratio of the Aid received (current US$) of Marshall Islands in 1995 to that in 1998?
Ensure brevity in your answer.  0.77. What is the ratio of the Aid received (current US$) of Georgia in 1996 to that in 1997?
Ensure brevity in your answer.  1.28. What is the ratio of the Aid received (current US$) in Haiti in 1996 to that in 1997?
Make the answer very short. 1.13. What is the ratio of the Aid received (current US$) of Marshall Islands in 1996 to that in 1997?
Offer a very short reply. 1.16. What is the ratio of the Aid received (current US$) of Georgia in 1996 to that in 1998?
Offer a terse response. 1.48. What is the ratio of the Aid received (current US$) of Haiti in 1996 to that in 1998?
Offer a terse response. 0.9. What is the ratio of the Aid received (current US$) of Marshall Islands in 1996 to that in 1998?
Provide a succinct answer. 1.45. What is the ratio of the Aid received (current US$) in Georgia in 1997 to that in 1998?
Give a very brief answer. 1.16. What is the ratio of the Aid received (current US$) of Haiti in 1997 to that in 1998?
Give a very brief answer. 0.8. What is the ratio of the Aid received (current US$) in Marshall Islands in 1997 to that in 1998?
Make the answer very short. 1.25. What is the difference between the highest and the second highest Aid received (current US$) in Georgia?
Provide a short and direct response. 6.75e+07. What is the difference between the highest and the second highest Aid received (current US$) of Haiti?
Ensure brevity in your answer.  1.22e+08. What is the difference between the highest and the second highest Aid received (current US$) of Marshall Islands?
Keep it short and to the point. 1.00e+07. What is the difference between the highest and the lowest Aid received (current US$) of Georgia?
Make the answer very short. 3.09e+08. What is the difference between the highest and the lowest Aid received (current US$) of Haiti?
Give a very brief answer. 6.21e+08. What is the difference between the highest and the lowest Aid received (current US$) of Marshall Islands?
Provide a short and direct response. 7.27e+07. 